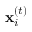Convert formula to latex. <formula><loc_0><loc_0><loc_500><loc_500>x _ { i } ^ { ( t ) }</formula> 